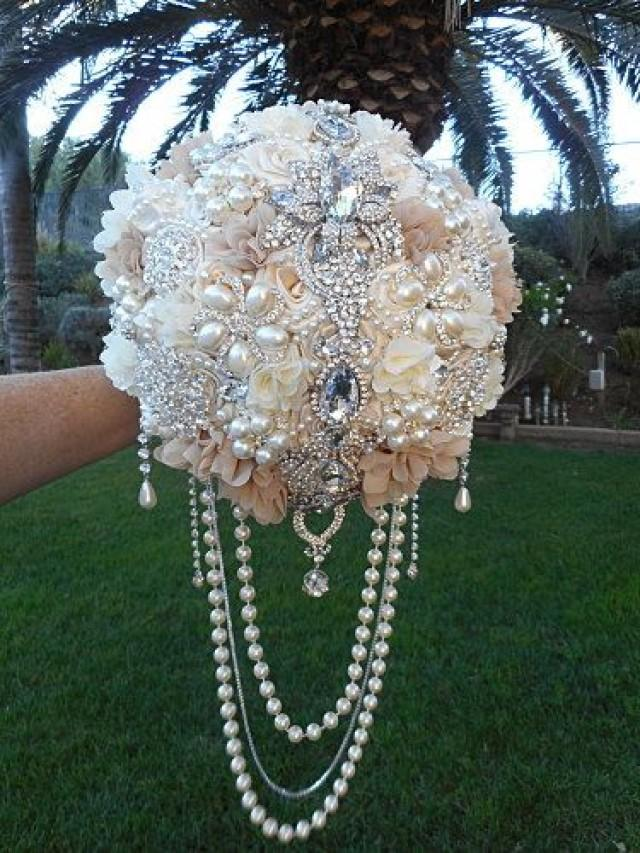Considering the design elements and materials used in the creation of this bouquet, what might be the occasion or event for which this bouquet is intended, and why would this particular style be chosen? The bouquet is intended for a wedding, discernible by its opulent design and the traditional use of white and cream colors, which are commonly associated with bridal attire and accessories. This particular style, featuring an abundance of pearls and crystal brooches, suggests a desire for a luxurious and vintage aesthetic, possibly for a bride who appreciates a blend of traditional beauty with a touch of glamour. The artificial nature of the flowers indicates a keepsake intention, allowing the bouquet to be preserved as a memento of the special day. 